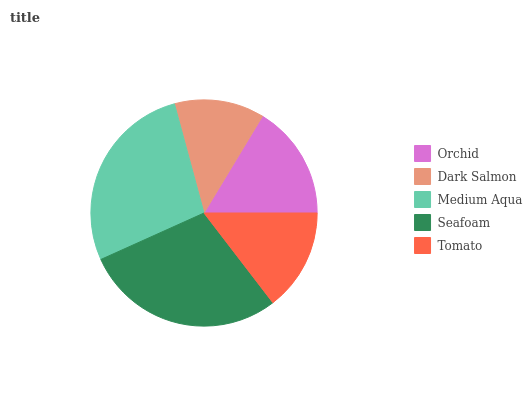Is Dark Salmon the minimum?
Answer yes or no. Yes. Is Seafoam the maximum?
Answer yes or no. Yes. Is Medium Aqua the minimum?
Answer yes or no. No. Is Medium Aqua the maximum?
Answer yes or no. No. Is Medium Aqua greater than Dark Salmon?
Answer yes or no. Yes. Is Dark Salmon less than Medium Aqua?
Answer yes or no. Yes. Is Dark Salmon greater than Medium Aqua?
Answer yes or no. No. Is Medium Aqua less than Dark Salmon?
Answer yes or no. No. Is Orchid the high median?
Answer yes or no. Yes. Is Orchid the low median?
Answer yes or no. Yes. Is Seafoam the high median?
Answer yes or no. No. Is Seafoam the low median?
Answer yes or no. No. 